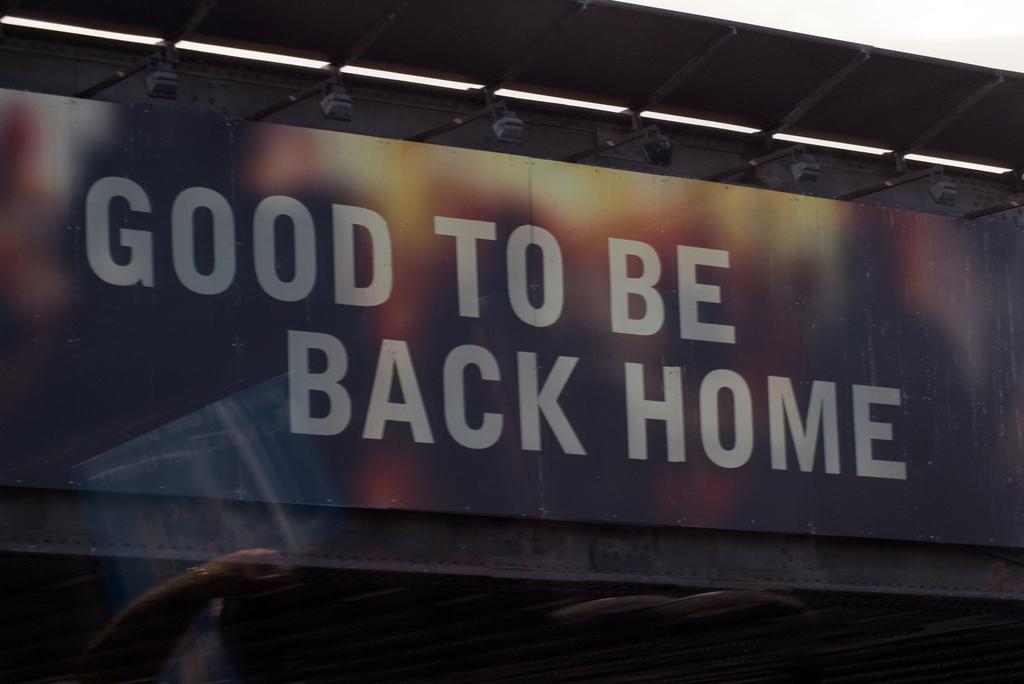What does the sign say?
Your answer should be very brief. Good to be back home. 